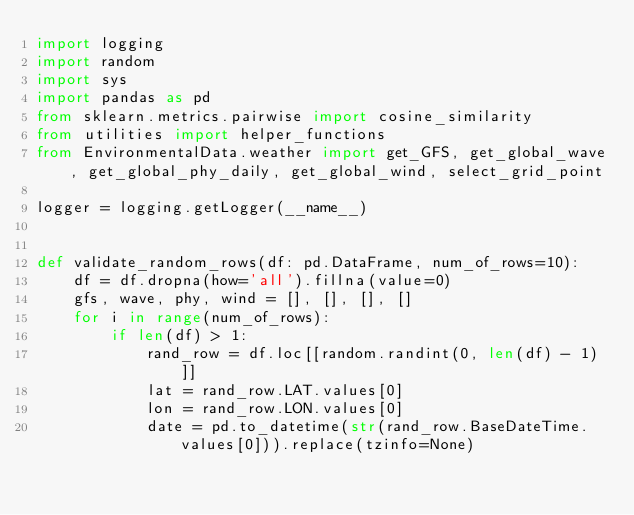Convert code to text. <code><loc_0><loc_0><loc_500><loc_500><_Python_>import logging
import random
import sys
import pandas as pd
from sklearn.metrics.pairwise import cosine_similarity
from utilities import helper_functions
from EnvironmentalData.weather import get_GFS, get_global_wave, get_global_phy_daily, get_global_wind, select_grid_point

logger = logging.getLogger(__name__)


def validate_random_rows(df: pd.DataFrame, num_of_rows=10):
    df = df.dropna(how='all').fillna(value=0)
    gfs, wave, phy, wind = [], [], [], []
    for i in range(num_of_rows):
        if len(df) > 1:
            rand_row = df.loc[[random.randint(0, len(df) - 1)]]
            lat = rand_row.LAT.values[0]
            lon = rand_row.LON.values[0]
            date = pd.to_datetime(str(rand_row.BaseDateTime.values[0])).replace(tzinfo=None)</code> 